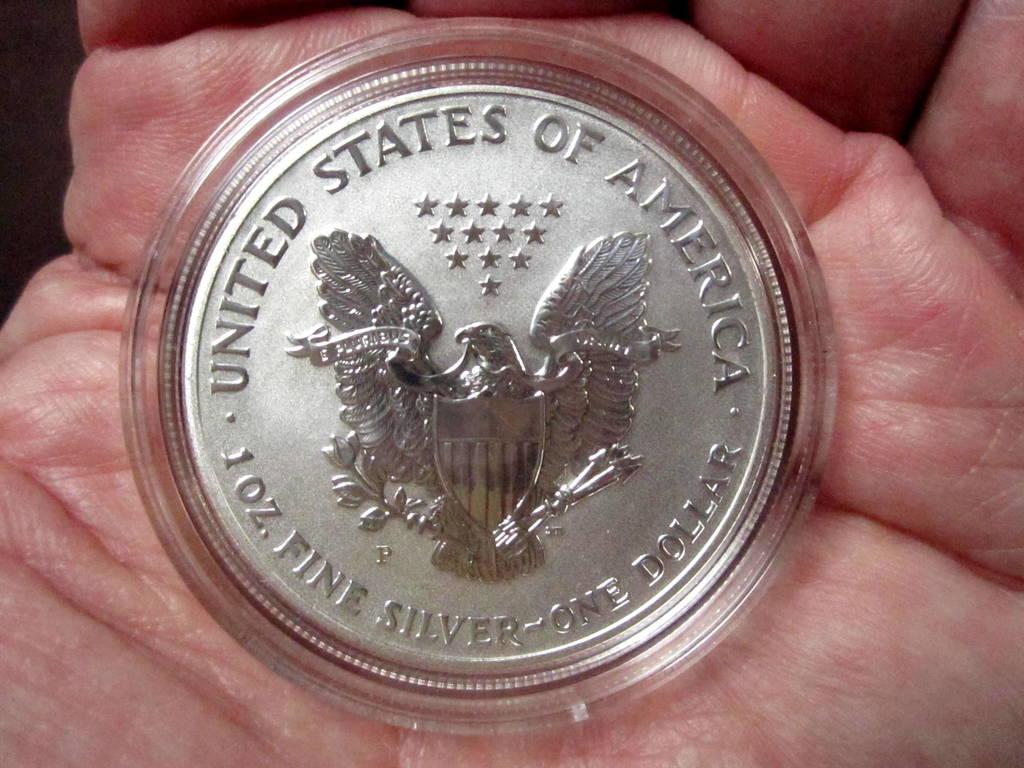<image>
Create a compact narrative representing the image presented. a silver coin that says 'united states of america' on it above an eagle 